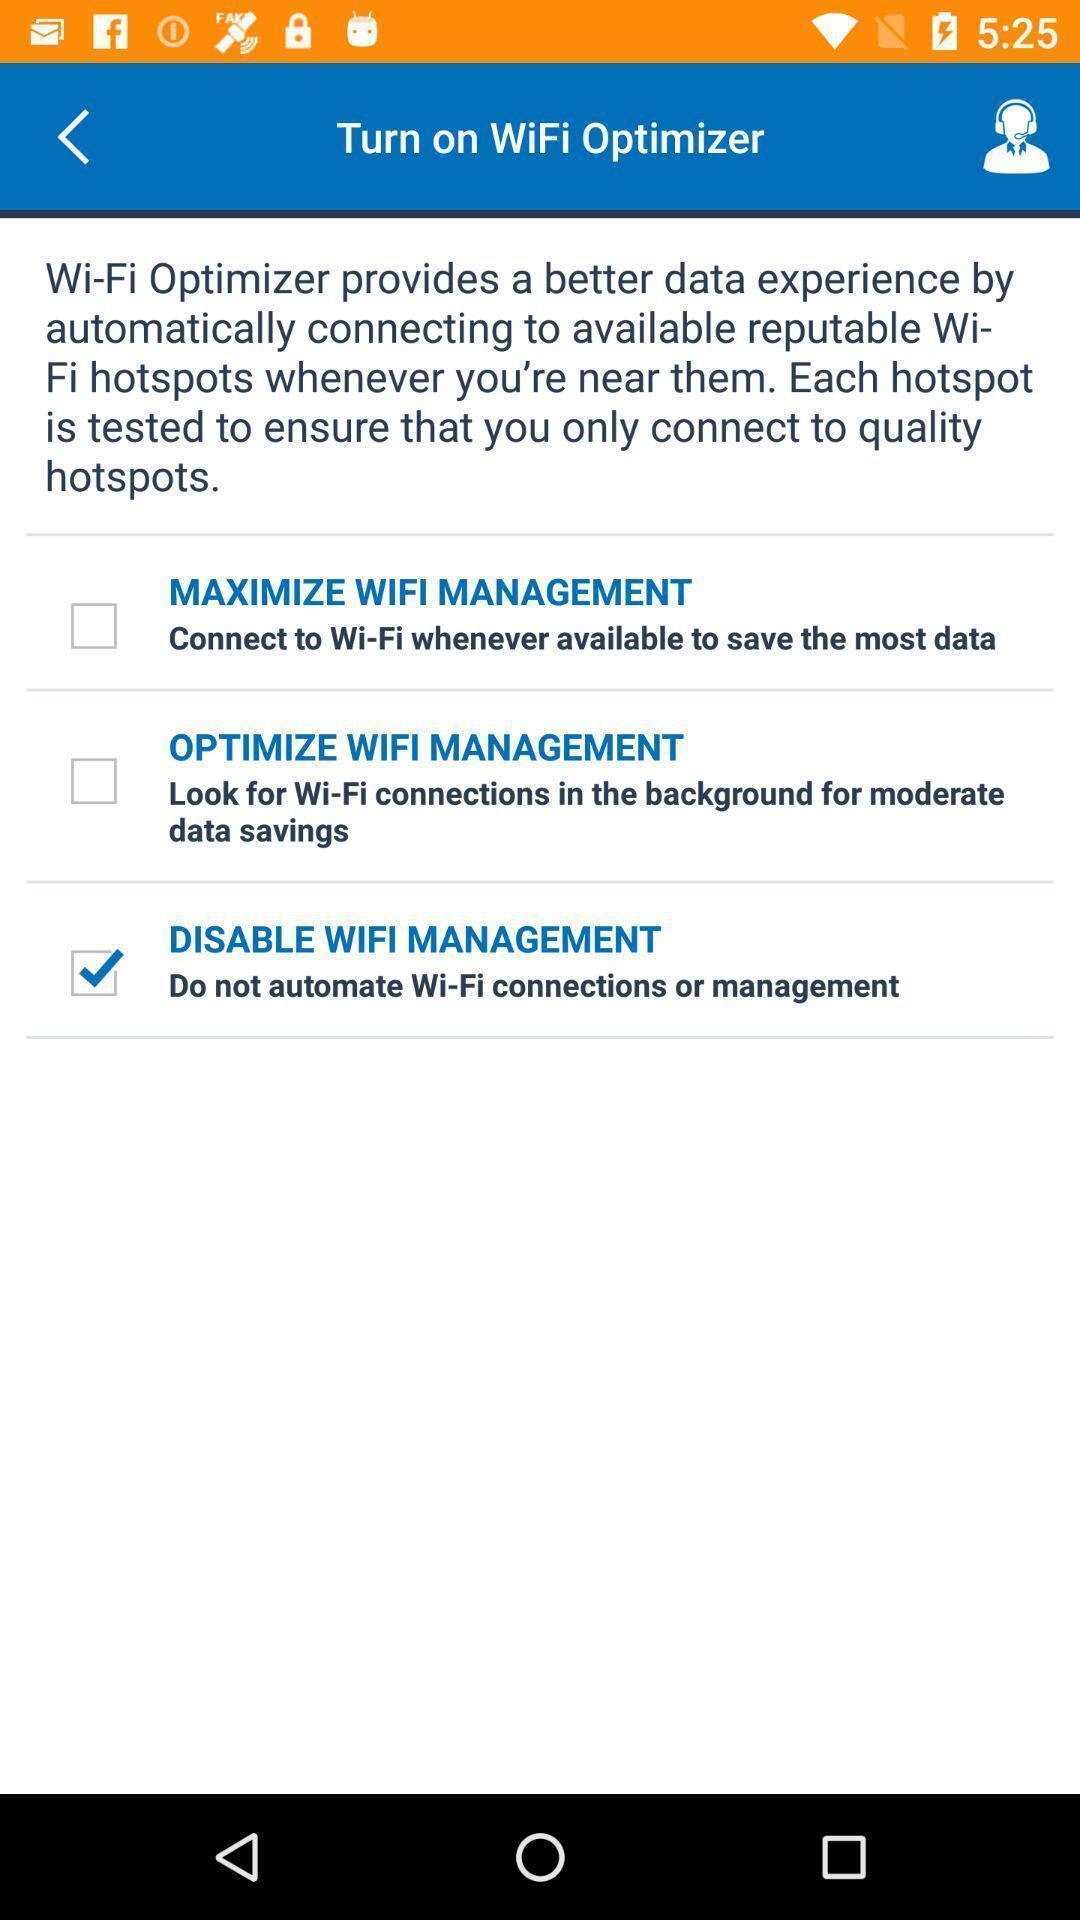What can you discern from this picture? Screen showing turn on wifi optimizer with options to select. 